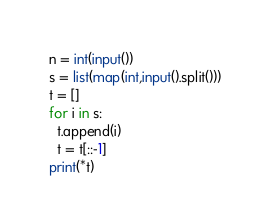Convert code to text. <code><loc_0><loc_0><loc_500><loc_500><_Python_>n = int(input())
s = list(map(int,input().split()))
t = []
for i in s:
  t.append(i)
  t = t[::-1]
print(*t)</code> 